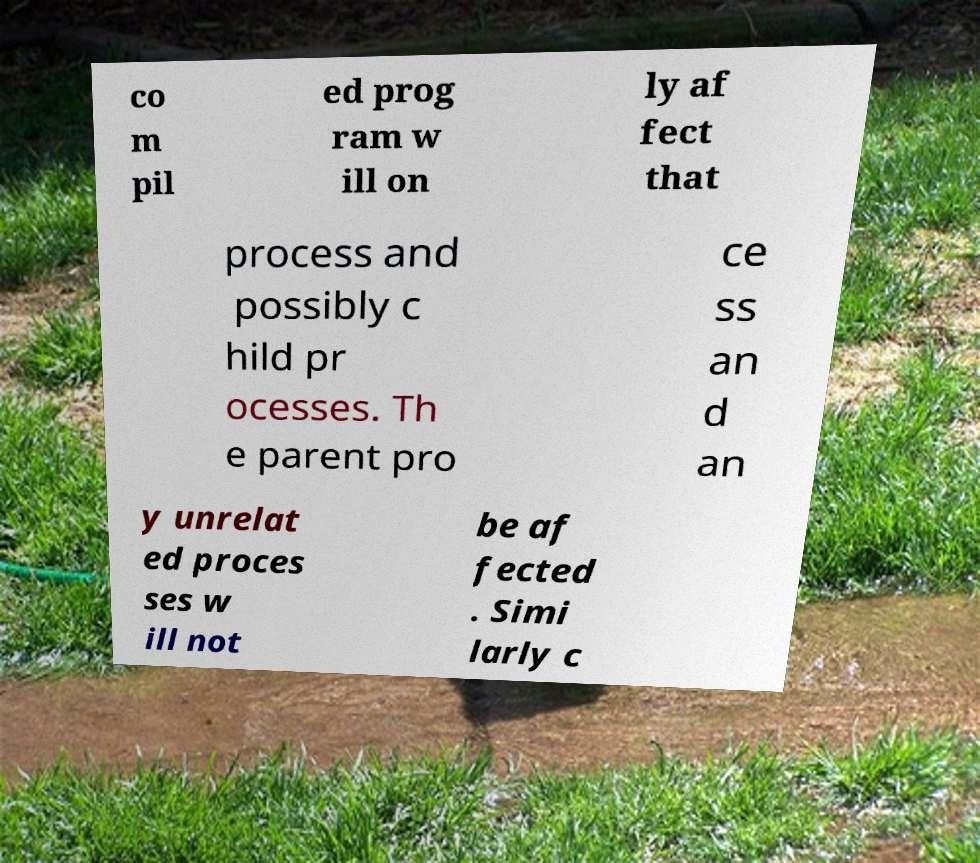For documentation purposes, I need the text within this image transcribed. Could you provide that? co m pil ed prog ram w ill on ly af fect that process and possibly c hild pr ocesses. Th e parent pro ce ss an d an y unrelat ed proces ses w ill not be af fected . Simi larly c 